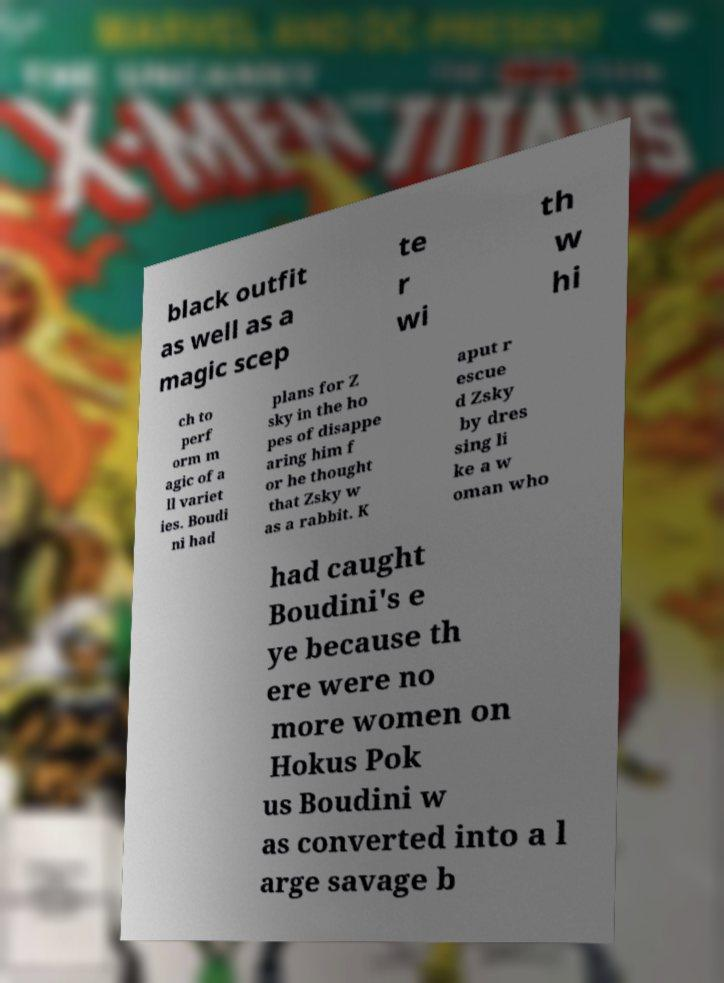Can you read and provide the text displayed in the image?This photo seems to have some interesting text. Can you extract and type it out for me? black outfit as well as a magic scep te r wi th w hi ch to perf orm m agic of a ll variet ies. Boudi ni had plans for Z sky in the ho pes of disappe aring him f or he thought that Zsky w as a rabbit. K aput r escue d Zsky by dres sing li ke a w oman who had caught Boudini's e ye because th ere were no more women on Hokus Pok us Boudini w as converted into a l arge savage b 